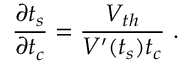Convert formula to latex. <formula><loc_0><loc_0><loc_500><loc_500>\frac { \partial t _ { s } } { \partial t _ { c } } = \frac { V _ { t h } } { V ^ { \prime } ( t _ { s } ) t _ { c } } .</formula> 